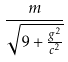Convert formula to latex. <formula><loc_0><loc_0><loc_500><loc_500>\frac { m } { \sqrt { 9 + \frac { g ^ { 2 } } { c ^ { 2 } } } }</formula> 